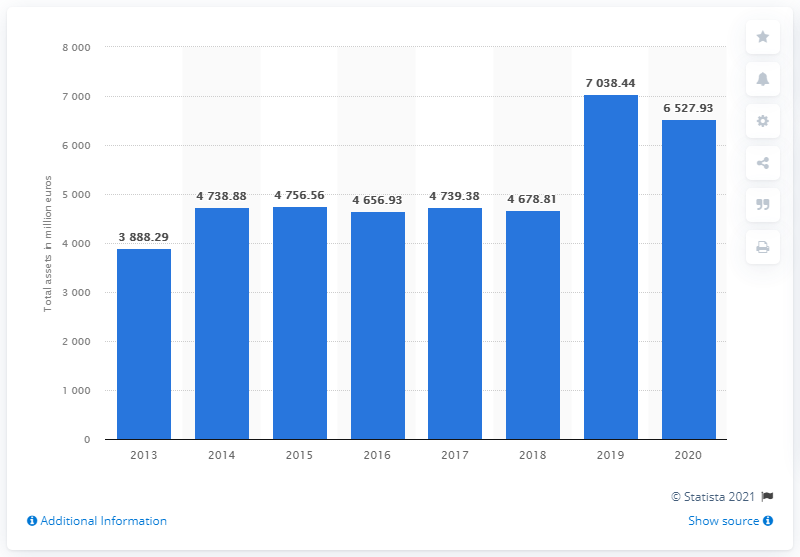Indicate a few pertinent items in this graphic. According to the information available, in 2020, Prada's assets were valued at approximately 6527.93. 